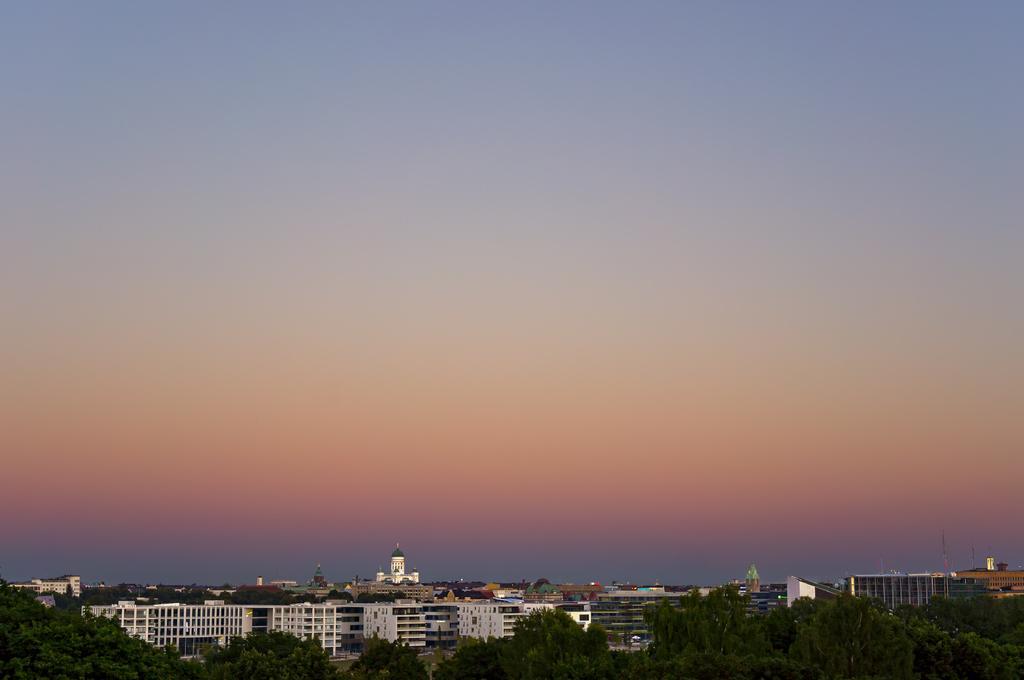Can you describe this image briefly? This picture is clicked outside the city. In the foreground we can see the trees. In the center we can see the buildings and the towers and the sky and many other objects. 